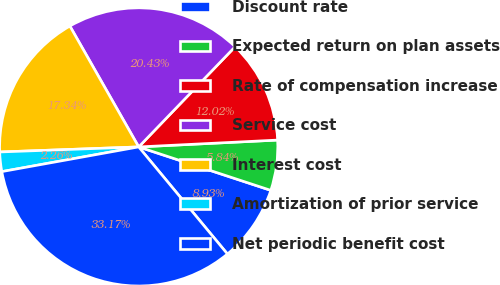Convert chart. <chart><loc_0><loc_0><loc_500><loc_500><pie_chart><fcel>Discount rate<fcel>Expected return on plan assets<fcel>Rate of compensation increase<fcel>Service cost<fcel>Interest cost<fcel>Amortization of prior service<fcel>Net periodic benefit cost<nl><fcel>8.93%<fcel>5.84%<fcel>12.02%<fcel>20.43%<fcel>17.34%<fcel>2.26%<fcel>33.17%<nl></chart> 